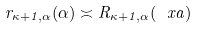<formula> <loc_0><loc_0><loc_500><loc_500>r _ { \kappa + 1 , \alpha } ( \alpha ) \asymp R _ { \kappa + 1 , \alpha } ( \ x a )</formula> 